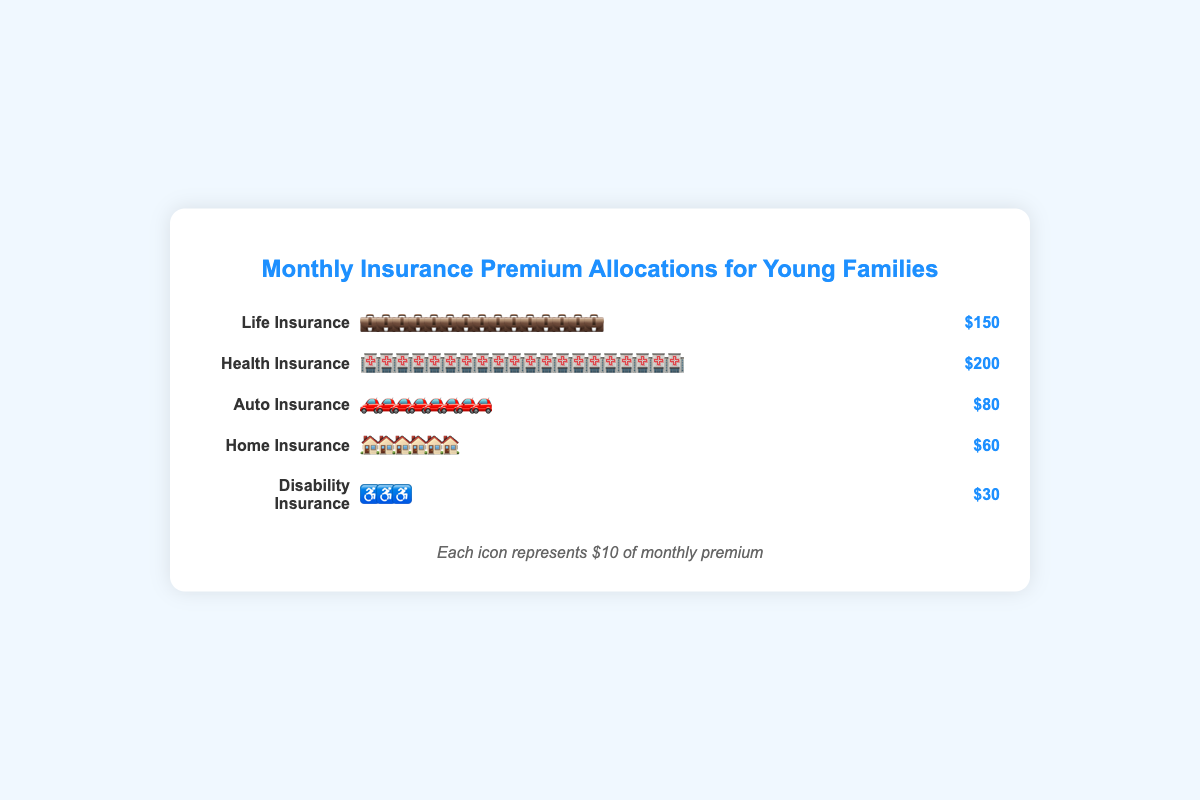What's the title of the figure? The title is displayed at the top of the figure in a larger, colored font. It reads "Monthly Insurance Premium Allocations for Young Families".
Answer: Monthly Insurance Premium Allocations for Young Families Which category has the highest monthly premium allocation? By observing the lengths and number of icons in each row, we can see that "Health Insurance" has the most icons, indicating it has the highest allocation of $200.
Answer: Health Insurance How much is allocated to Home Insurance monthly? The icons next to "Home Insurance" total 6 icons, each representing $10. Therefore, it sums up to $60. This is also explicitly stated next to the icons.
Answer: $60 What's the total monthly premium allocation across all categories? The total monthly allocation is provided at the bottom of the data section. It sums up to $520.
Answer: $520 How many categories of insurance are there in total? By counting the rows, there are a total of five categories: Life Insurance, Health Insurance, Auto Insurance, Home Insurance, and Disability Insurance.
Answer: 5 Which has a higher allocation, Life Insurance or Auto Insurance? Life Insurance has 15 icons totaling $150, while Auto Insurance has 8 icons totaling $80. Therefore, Life Insurance has a higher allocation.
Answer: Life Insurance What's the difference in monthly premium allocation between Health Insurance and Disability Insurance? Health Insurance has $200 allocated while Disability Insurance has $30. The difference is calculated as $200 - $30.
Answer: $170 What's the average monthly premium allocation per category? The average is calculated by dividing the total premium allocation by the number of categories: $520 / 5.
Answer: $104 How many more dollars are allocated to Life Insurance compared to Disability Insurance? Life Insurance has $150 allocated, while Disability Insurance has $30. The difference is $150 - $30.
Answer: $120 What does each icon represent in terms of dollar value? It is explicitly stated in the legend at the bottom of the figure, saying "Each icon represents $10 of monthly premium".
Answer: $10 